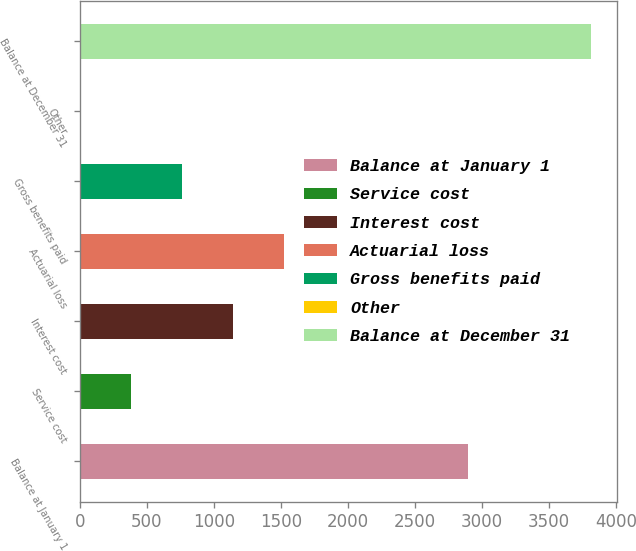Convert chart to OTSL. <chart><loc_0><loc_0><loc_500><loc_500><bar_chart><fcel>Balance at January 1<fcel>Service cost<fcel>Interest cost<fcel>Actuarial loss<fcel>Gross benefits paid<fcel>Other<fcel>Balance at December 31<nl><fcel>2899<fcel>382.6<fcel>1145.8<fcel>1527.4<fcel>764.2<fcel>1<fcel>3817<nl></chart> 